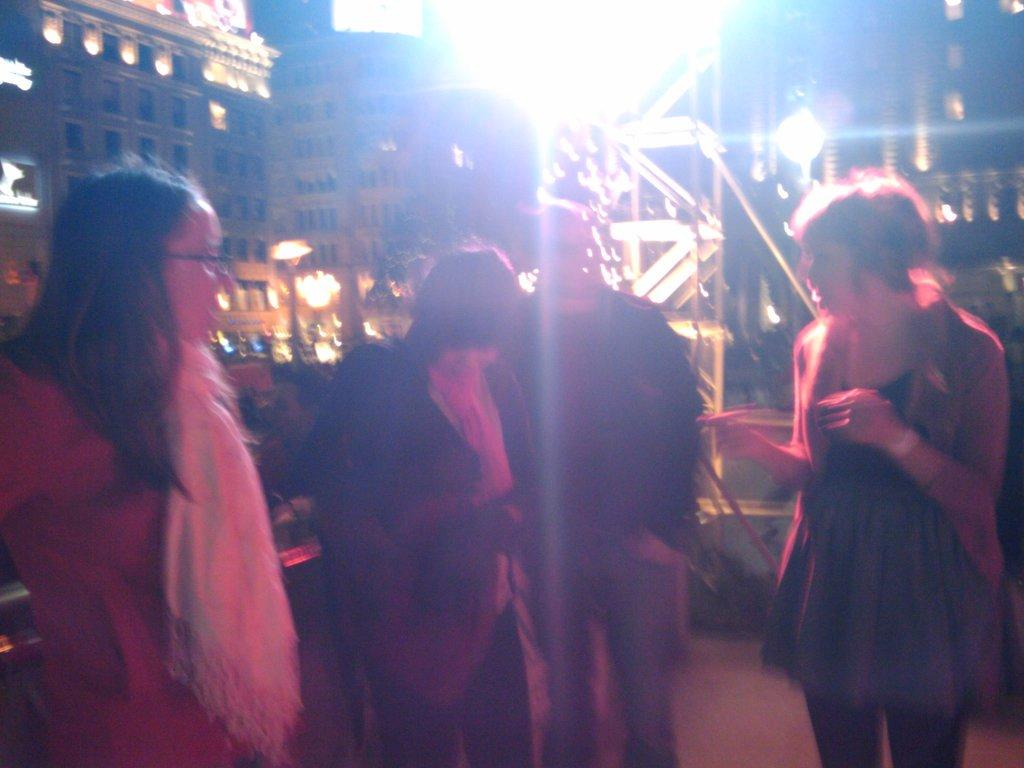Where was the image taken? The image was taken indoors. What can be seen in the foreground of the image? There is a group of people standing in the foreground. What is visible on the ground in the foreground? The ground is visible in the foreground. What can be seen in the background of the image? There are buildings, lights, and metal rods visible in the background. What type of cake is being served in the image? There is no cake present in the image. What is the purpose of the metal rods in the background? The purpose of the metal rods in the background is not mentioned in the image, so it cannot be determined from the image alone. 